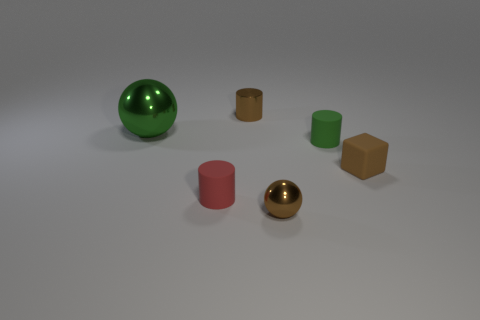Add 1 small yellow shiny blocks. How many objects exist? 7 Subtract all blocks. How many objects are left? 5 Subtract all small brown balls. Subtract all brown cylinders. How many objects are left? 4 Add 5 green shiny objects. How many green shiny objects are left? 6 Add 5 small brown matte cylinders. How many small brown matte cylinders exist? 5 Subtract 1 brown cubes. How many objects are left? 5 